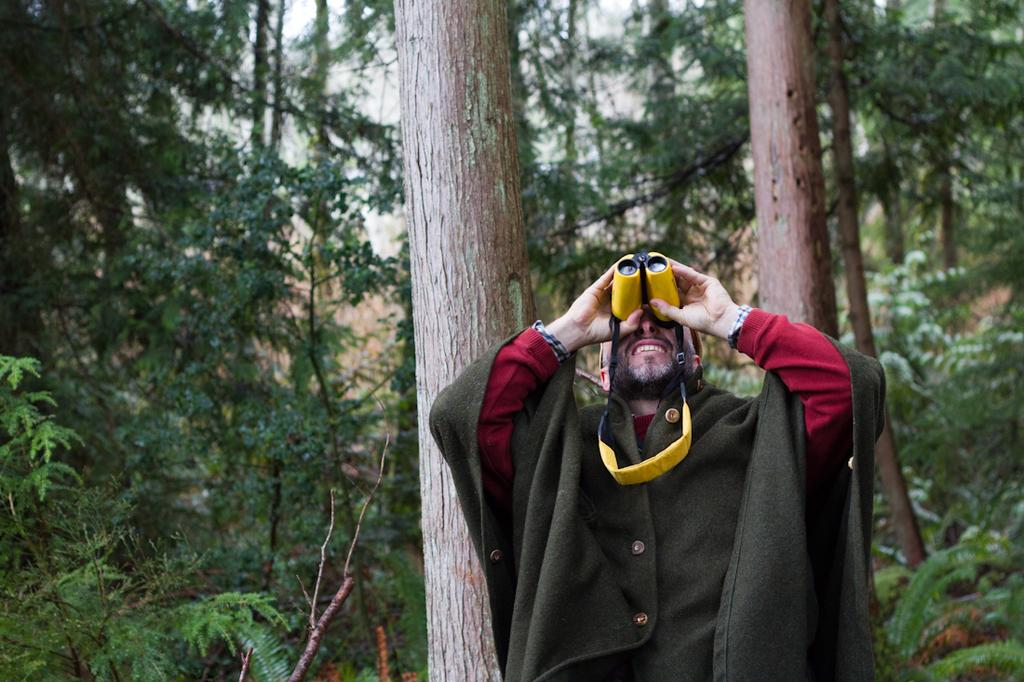Who is present in the image? There is a man in the image. What is the man holding in the image? The man is holding a binocular. What can be seen in the background of the image? There are trees in the background of the image. How would you describe the sky in the image? The sky is cloudy in the image. What is the man's desire for downtown in the image? There is no mention of downtown or any desires in the image; it only shows a man holding a binocular with trees and a cloudy sky in the background. 